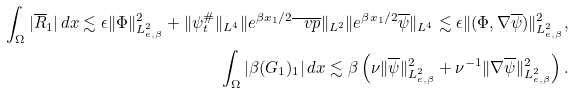Convert formula to latex. <formula><loc_0><loc_0><loc_500><loc_500>\int _ { \Omega } | \overline { R } _ { 1 } | \, d x \lesssim \epsilon \| \Phi \| ^ { 2 } _ { L ^ { 2 } _ { e , \beta } } + \| \psi ^ { \# } _ { t } \| _ { L ^ { 4 } } \| e ^ { \beta x _ { 1 } / 2 } \overline { \ v p } \| _ { L ^ { 2 } } \| e ^ { \beta x _ { 1 } / 2 } \overline { \psi } \| _ { L ^ { 4 } } \lesssim \epsilon \| ( \Phi , \nabla \overline { \psi } ) \| ^ { 2 } _ { L ^ { 2 } _ { e , \beta } } , \\ \int _ { \Omega } | \beta ( G _ { 1 } ) _ { 1 } | \, d x \lesssim \beta \left ( \nu \| \overline { \psi } \| ^ { 2 } _ { L ^ { 2 } _ { e , \beta } } + \nu ^ { - 1 } \| \nabla \overline { \psi } \| ^ { 2 } _ { L ^ { 2 } _ { e , \beta } } \right ) .</formula> 